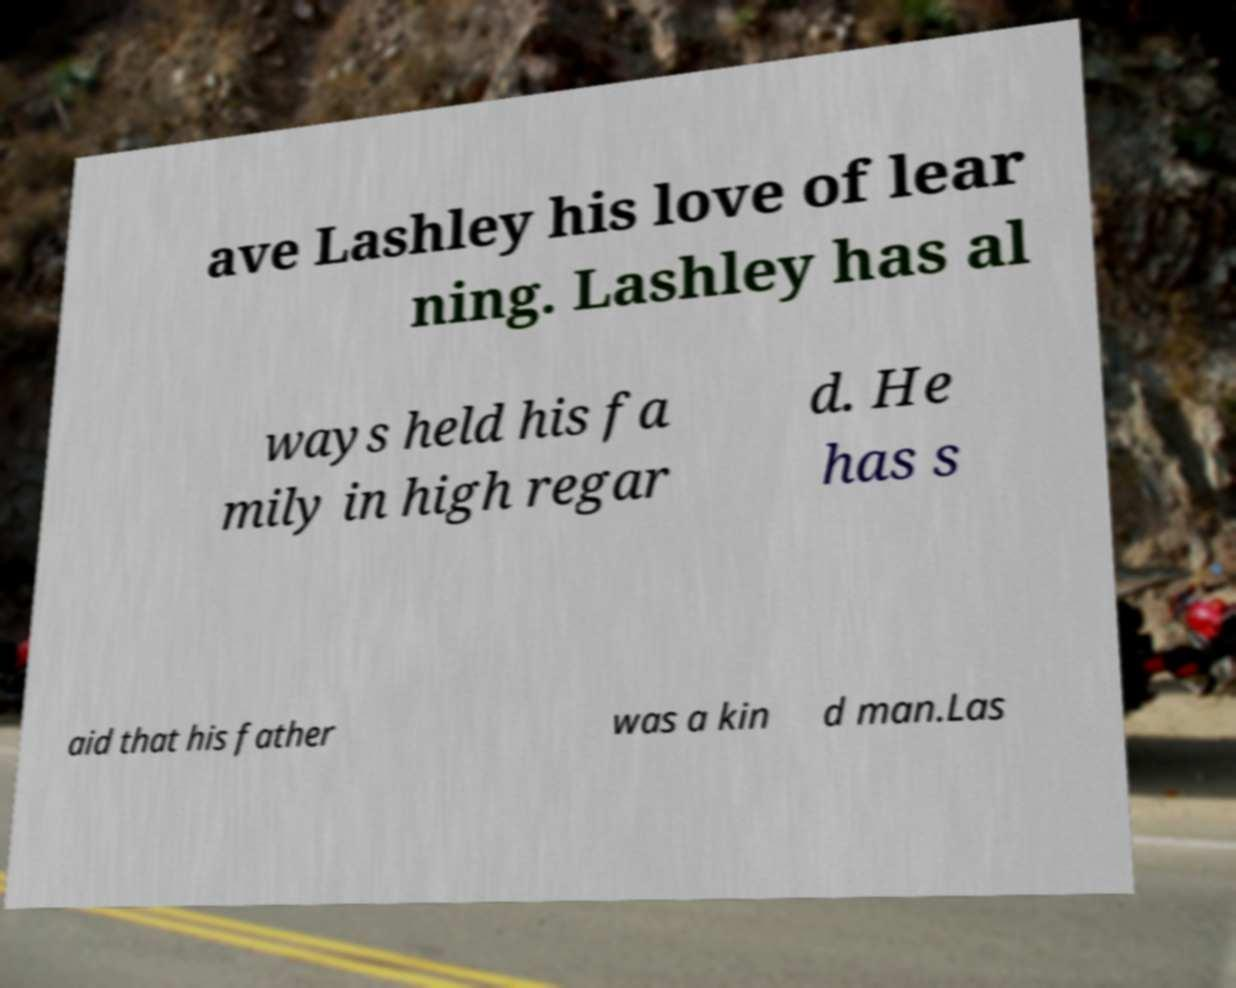For documentation purposes, I need the text within this image transcribed. Could you provide that? ave Lashley his love of lear ning. Lashley has al ways held his fa mily in high regar d. He has s aid that his father was a kin d man.Las 